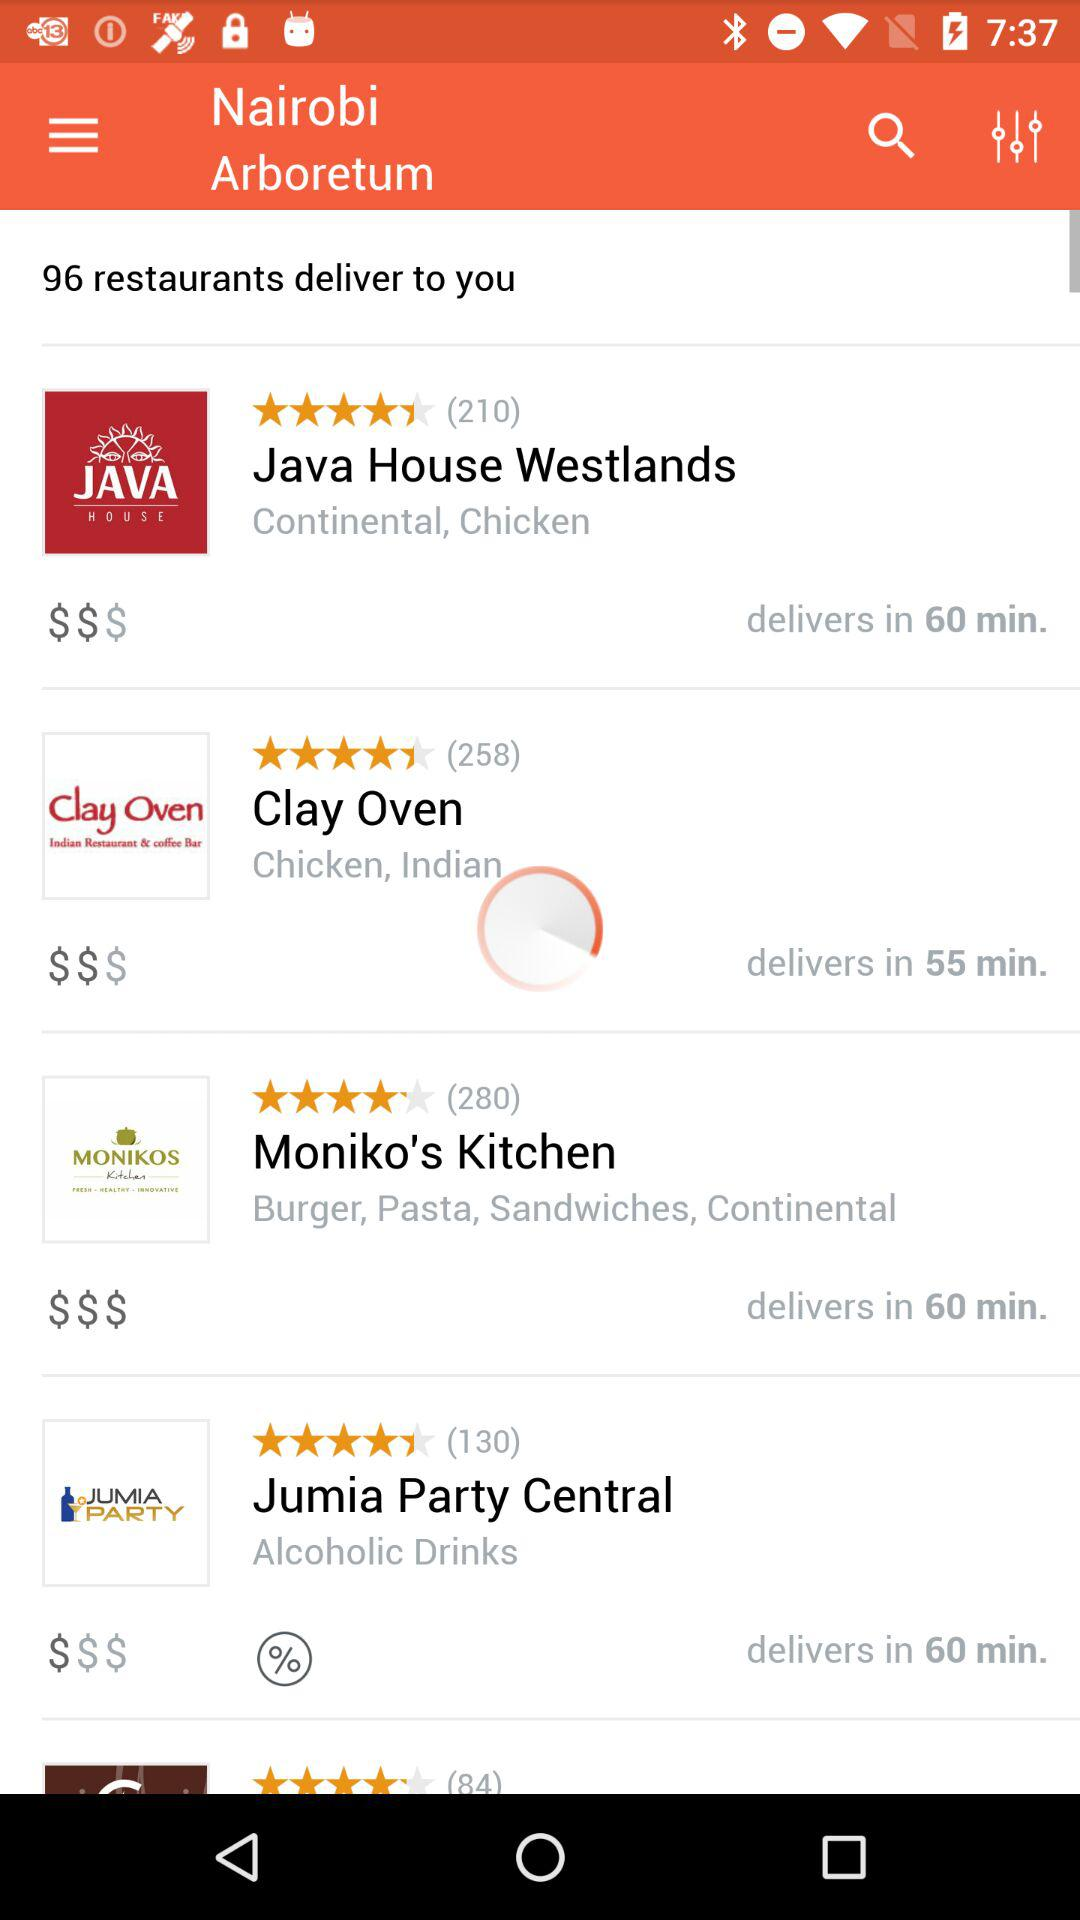What is the rating of the clay oven? The rating of the clay oven is 4.4 stars. 